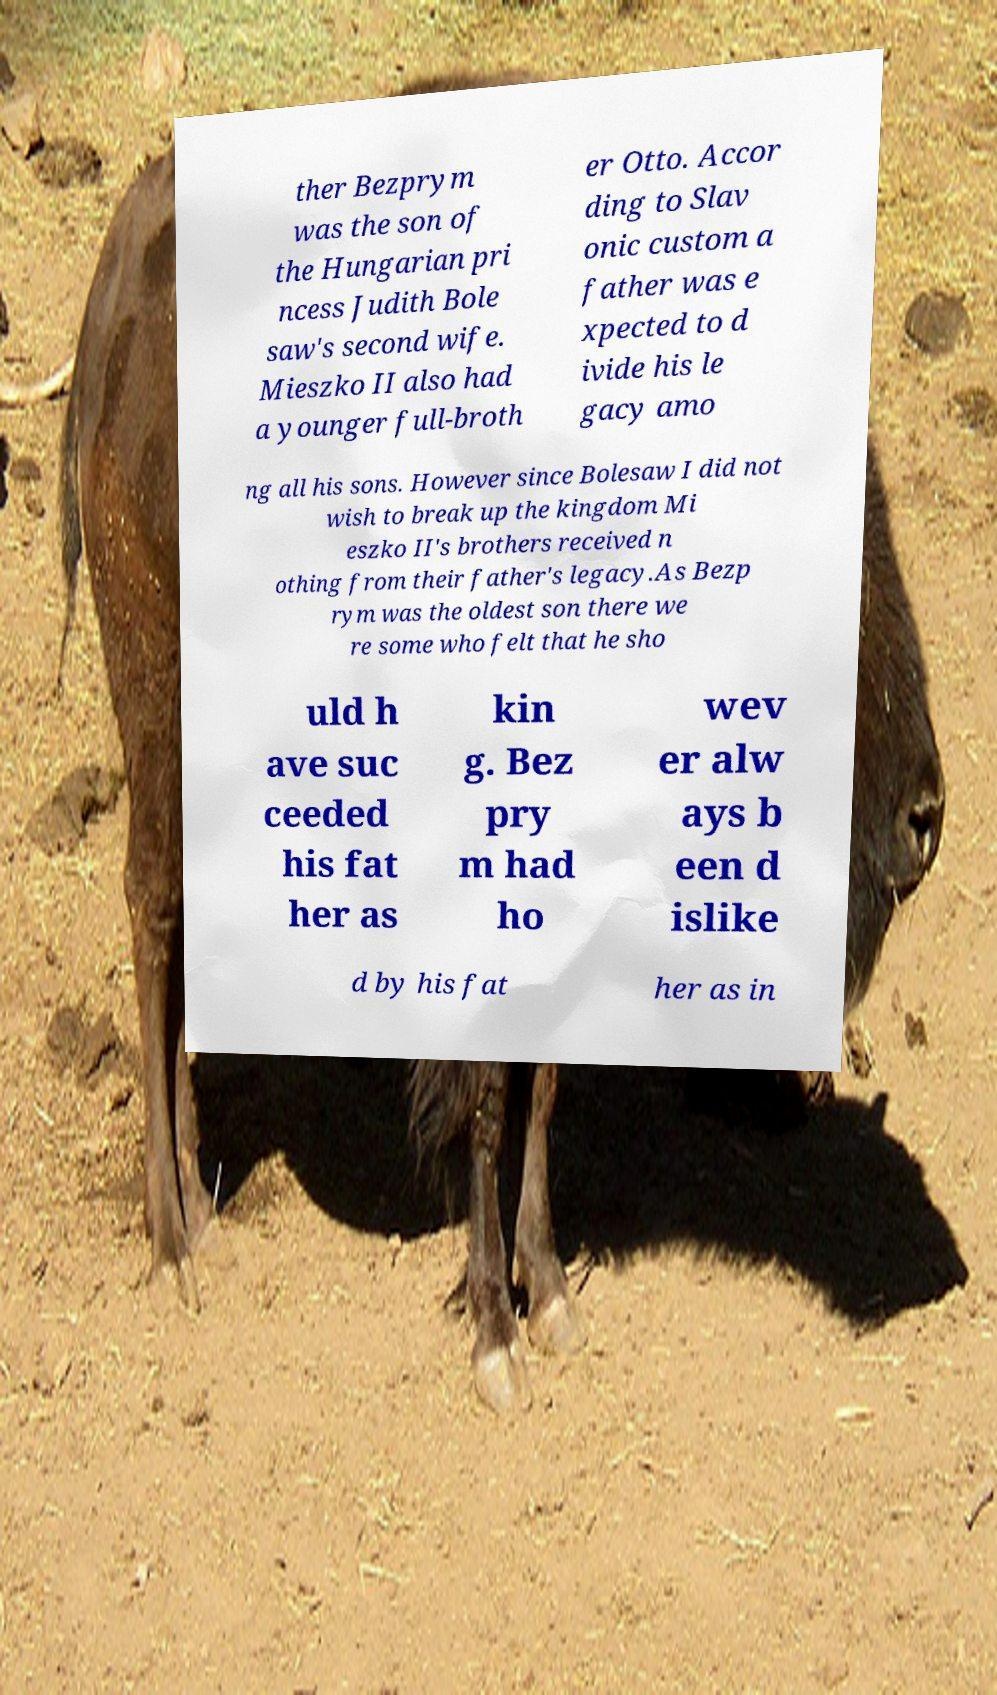Can you accurately transcribe the text from the provided image for me? ther Bezprym was the son of the Hungarian pri ncess Judith Bole saw's second wife. Mieszko II also had a younger full-broth er Otto. Accor ding to Slav onic custom a father was e xpected to d ivide his le gacy amo ng all his sons. However since Bolesaw I did not wish to break up the kingdom Mi eszko II's brothers received n othing from their father's legacy.As Bezp rym was the oldest son there we re some who felt that he sho uld h ave suc ceeded his fat her as kin g. Bez pry m had ho wev er alw ays b een d islike d by his fat her as in 